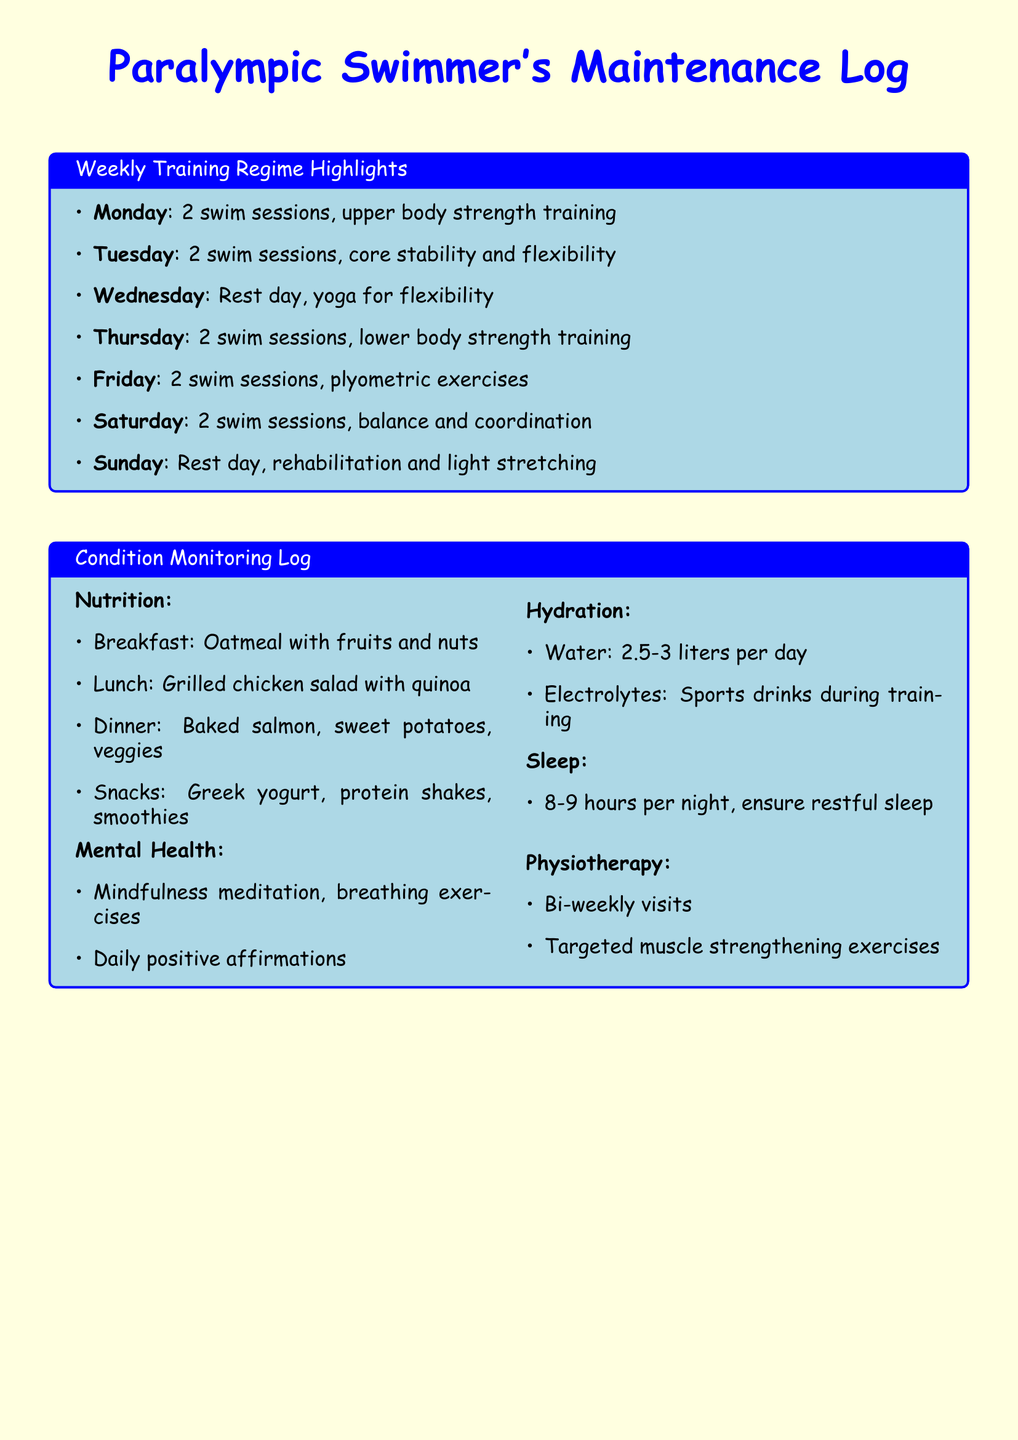What are the main exercises on Fridays? The document lists plyometric exercises as the main exercises for Friday.
Answer: plyometric exercises How many swim sessions are there on Thursdays? The document specifies that there are 2 swim sessions on Thursdays.
Answer: 2 swim sessions What is the hydration target for water intake? The document states the hydration target is 2.5-3 liters per day.
Answer: 2.5-3 liters What are the achievements in this week? The document mentions personal bests in 100m Freestyle and 200m Individual Medley.
Answer: Personal best in 100m Freestyle, Personal best in 200m Individual Medley How often are physiotherapy visits scheduled? The document indicates that physiotherapy visits are bi-weekly.
Answer: bi-weekly Which day is dedicated to rest and rehabilitation? The document shows that Sunday is the day dedicated to rest and rehabilitation.
Answer: Sunday What type of training is emphasized on Tuesdays? The document states that core stability and flexibility training is emphasized on Tuesdays.
Answer: core stability and flexibility What is the focus for this week's goals? The document lists improving turn efficiency and reducing lap times by 2% as the focus.
Answer: Improve turn efficiency, Reduce lap times by 2% 